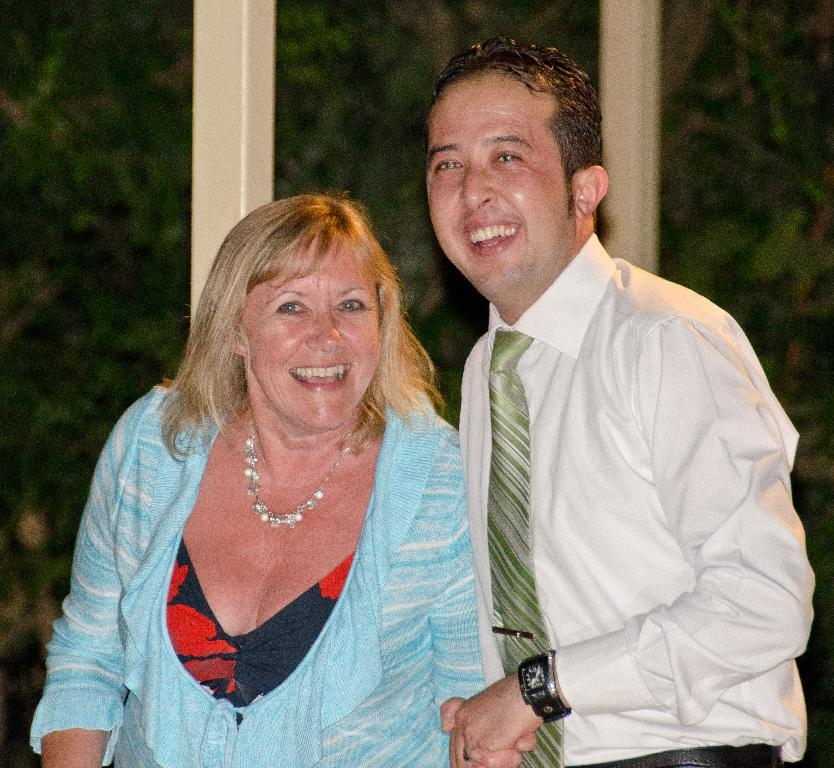Who is present in the image? There is a man and a lady in the image. What are the man and the lady doing in the image? Both the man and the lady are standing and smiling. What can be seen in the background of the image? There are trees and rods in the background of the image. What type of button can be seen on the man's shirt in the image? There is no button visible on the man's shirt in the image. Can you tell me how low the water is in the image? There is no water present in the image, so it is not possible to determine the water level. 